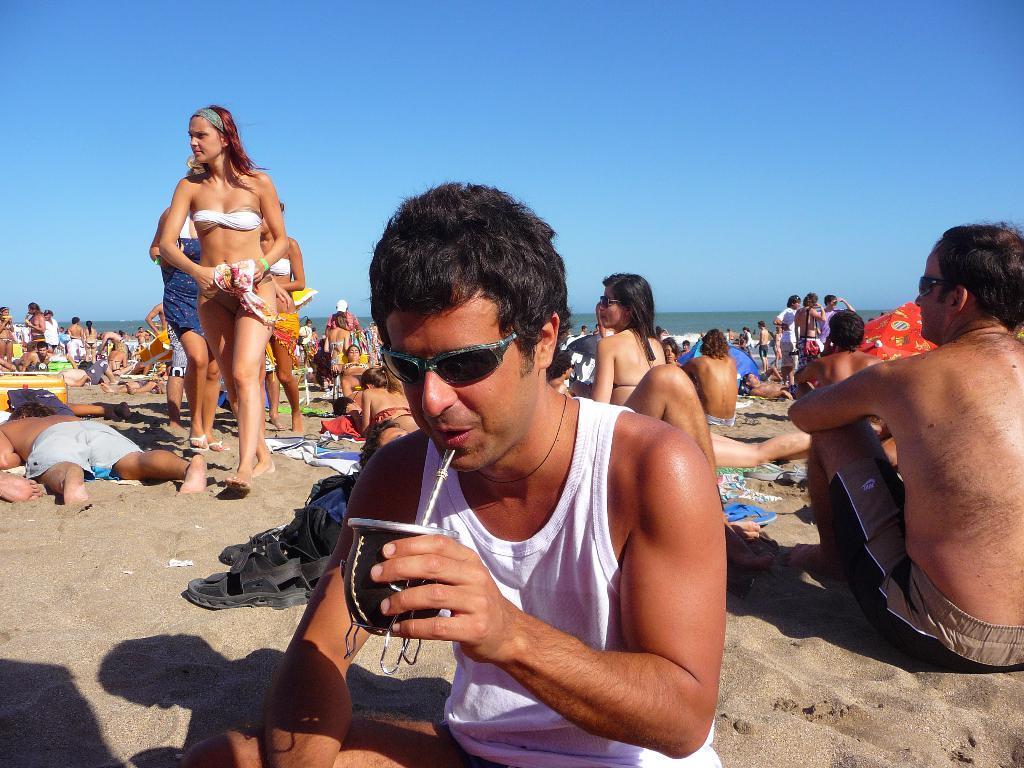How would you summarize this image in a sentence or two? There is one man sitting and drinking as we can see at the bottom of this image. We can see people in the background and the sky is at the top of this image. 